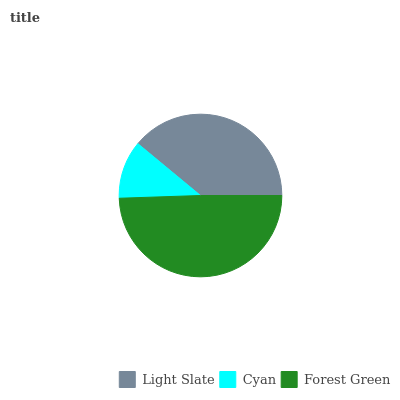Is Cyan the minimum?
Answer yes or no. Yes. Is Forest Green the maximum?
Answer yes or no. Yes. Is Forest Green the minimum?
Answer yes or no. No. Is Cyan the maximum?
Answer yes or no. No. Is Forest Green greater than Cyan?
Answer yes or no. Yes. Is Cyan less than Forest Green?
Answer yes or no. Yes. Is Cyan greater than Forest Green?
Answer yes or no. No. Is Forest Green less than Cyan?
Answer yes or no. No. Is Light Slate the high median?
Answer yes or no. Yes. Is Light Slate the low median?
Answer yes or no. Yes. Is Cyan the high median?
Answer yes or no. No. Is Forest Green the low median?
Answer yes or no. No. 